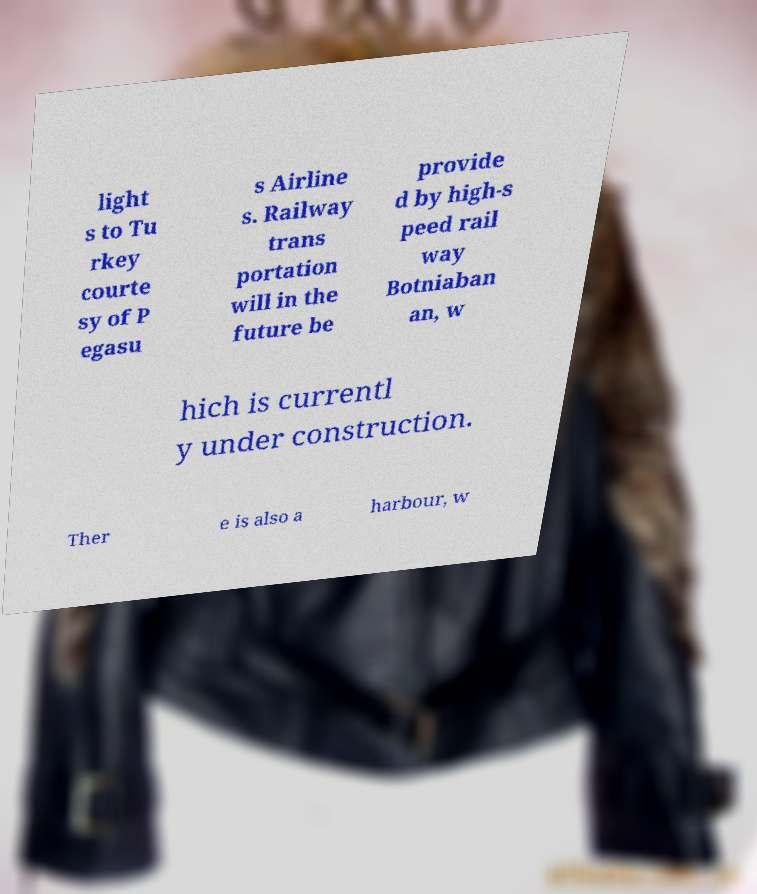Can you accurately transcribe the text from the provided image for me? light s to Tu rkey courte sy of P egasu s Airline s. Railway trans portation will in the future be provide d by high-s peed rail way Botniaban an, w hich is currentl y under construction. Ther e is also a harbour, w 